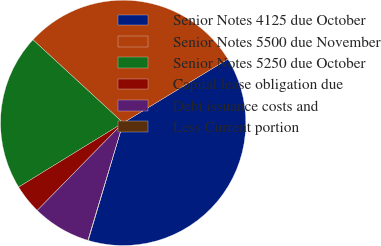<chart> <loc_0><loc_0><loc_500><loc_500><pie_chart><fcel>Senior Notes 4125 due October<fcel>Senior Notes 5500 due November<fcel>Senior Notes 5250 due October<fcel>Capital lease obligation due<fcel>Debt issuance costs and<fcel>Less Current portion<nl><fcel>38.29%<fcel>29.45%<fcel>20.62%<fcel>3.88%<fcel>7.7%<fcel>0.06%<nl></chart> 